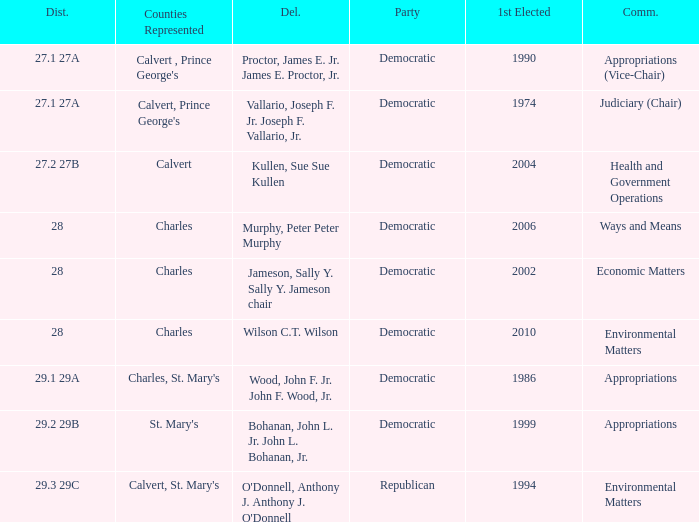Which was the district that had first elected greater than 2006 and is democratic? 28.0. 